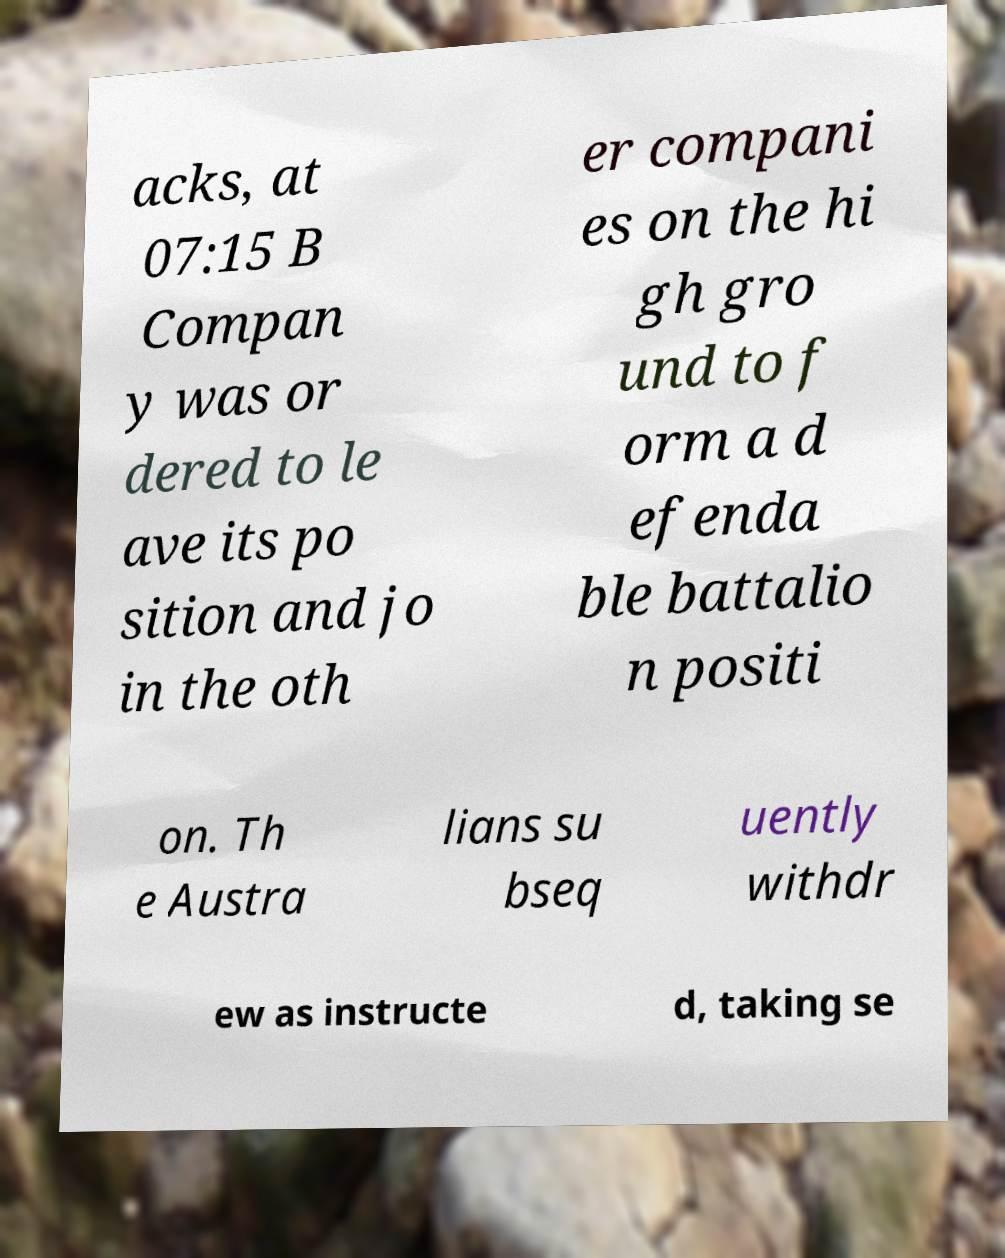Could you assist in decoding the text presented in this image and type it out clearly? acks, at 07:15 B Compan y was or dered to le ave its po sition and jo in the oth er compani es on the hi gh gro und to f orm a d efenda ble battalio n positi on. Th e Austra lians su bseq uently withdr ew as instructe d, taking se 